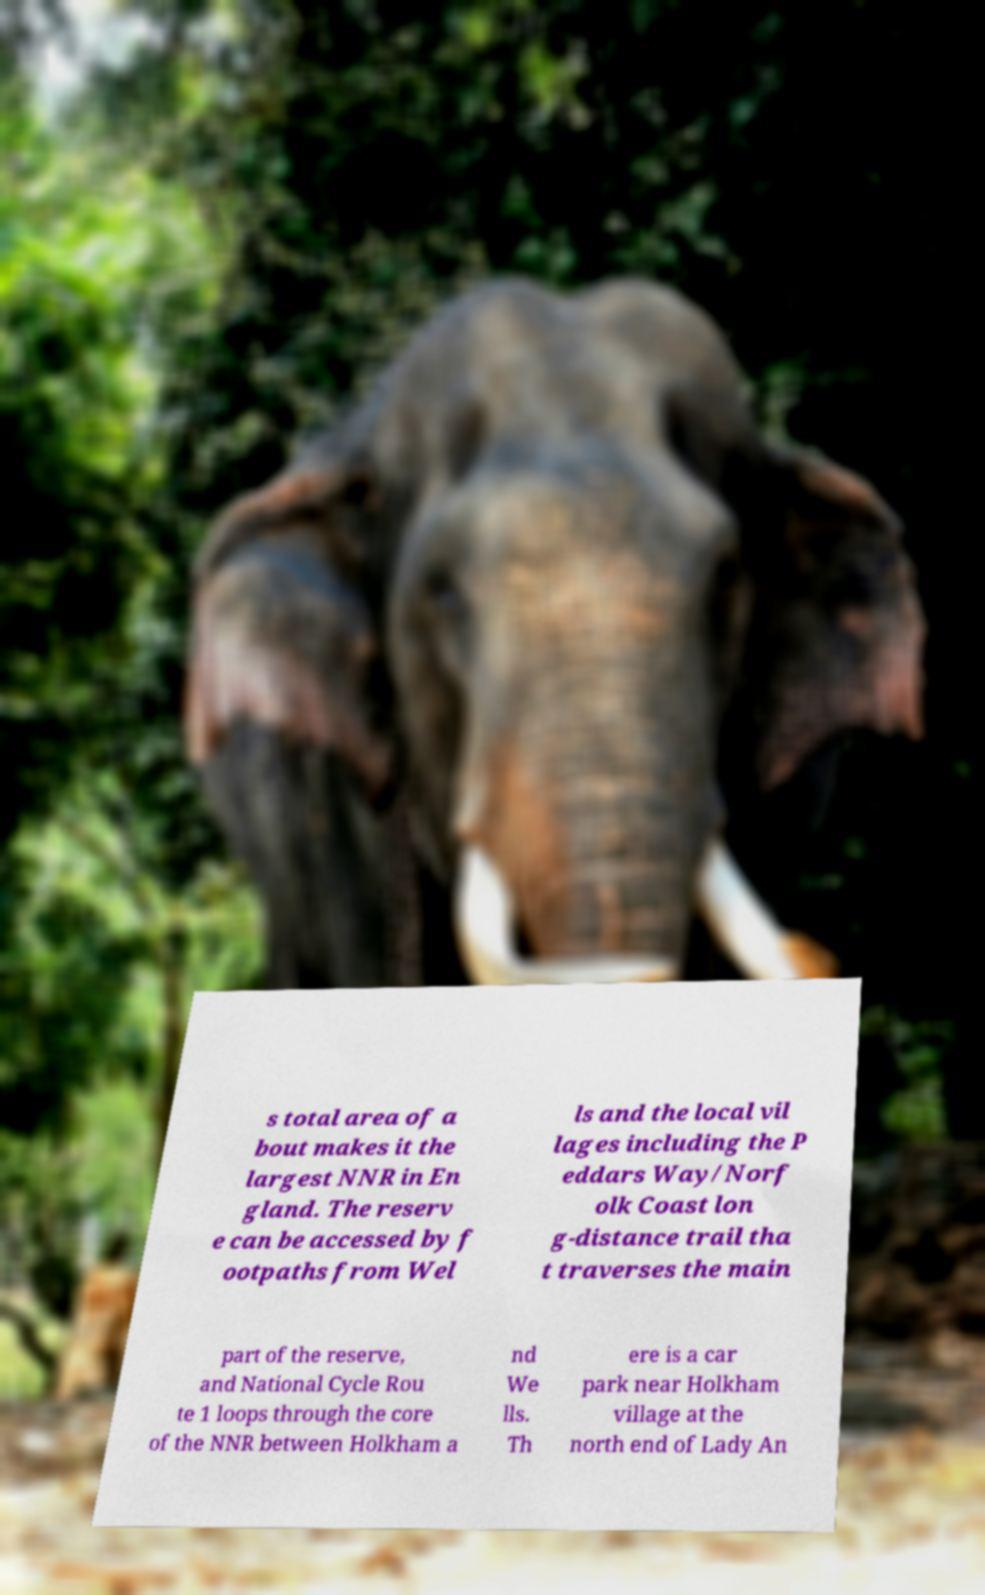For documentation purposes, I need the text within this image transcribed. Could you provide that? s total area of a bout makes it the largest NNR in En gland. The reserv e can be accessed by f ootpaths from Wel ls and the local vil lages including the P eddars Way/Norf olk Coast lon g-distance trail tha t traverses the main part of the reserve, and National Cycle Rou te 1 loops through the core of the NNR between Holkham a nd We lls. Th ere is a car park near Holkham village at the north end of Lady An 